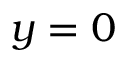Convert formula to latex. <formula><loc_0><loc_0><loc_500><loc_500>y = 0</formula> 